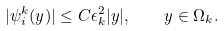<formula> <loc_0><loc_0><loc_500><loc_500>| \psi _ { i } ^ { k } ( y ) | \leq C \epsilon _ { k } ^ { 2 } | y | , \quad y \in \Omega _ { k } .</formula> 